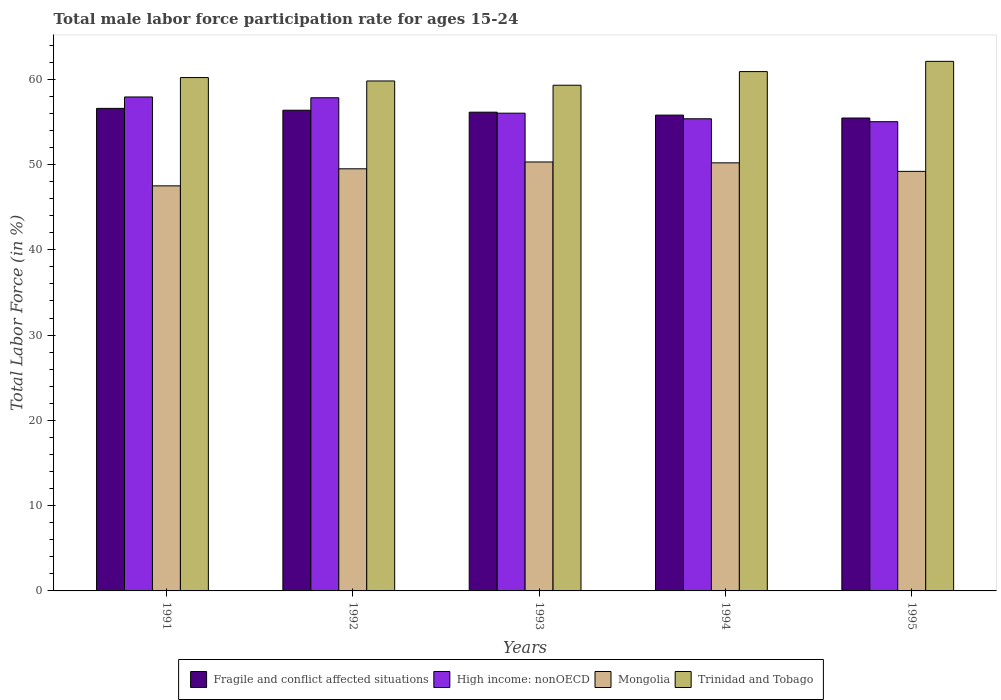How many bars are there on the 4th tick from the right?
Make the answer very short. 4. What is the male labor force participation rate in Trinidad and Tobago in 1994?
Provide a succinct answer. 60.9. Across all years, what is the maximum male labor force participation rate in Fragile and conflict affected situations?
Provide a succinct answer. 56.59. Across all years, what is the minimum male labor force participation rate in Trinidad and Tobago?
Provide a succinct answer. 59.3. In which year was the male labor force participation rate in Mongolia maximum?
Keep it short and to the point. 1993. What is the total male labor force participation rate in Mongolia in the graph?
Your response must be concise. 246.7. What is the difference between the male labor force participation rate in Trinidad and Tobago in 1991 and that in 1994?
Provide a short and direct response. -0.7. What is the difference between the male labor force participation rate in Fragile and conflict affected situations in 1994 and the male labor force participation rate in Trinidad and Tobago in 1995?
Provide a succinct answer. -6.3. What is the average male labor force participation rate in High income: nonOECD per year?
Keep it short and to the point. 56.43. In the year 1995, what is the difference between the male labor force participation rate in High income: nonOECD and male labor force participation rate in Fragile and conflict affected situations?
Make the answer very short. -0.43. What is the ratio of the male labor force participation rate in Trinidad and Tobago in 1992 to that in 1993?
Offer a terse response. 1.01. Is the male labor force participation rate in Fragile and conflict affected situations in 1991 less than that in 1993?
Provide a succinct answer. No. Is the difference between the male labor force participation rate in High income: nonOECD in 1992 and 1994 greater than the difference between the male labor force participation rate in Fragile and conflict affected situations in 1992 and 1994?
Give a very brief answer. Yes. What is the difference between the highest and the second highest male labor force participation rate in Mongolia?
Give a very brief answer. 0.1. What is the difference between the highest and the lowest male labor force participation rate in Mongolia?
Provide a succinct answer. 2.8. In how many years, is the male labor force participation rate in Trinidad and Tobago greater than the average male labor force participation rate in Trinidad and Tobago taken over all years?
Keep it short and to the point. 2. Is the sum of the male labor force participation rate in Fragile and conflict affected situations in 1993 and 1995 greater than the maximum male labor force participation rate in Mongolia across all years?
Your answer should be compact. Yes. What does the 2nd bar from the left in 1994 represents?
Provide a succinct answer. High income: nonOECD. What does the 1st bar from the right in 1994 represents?
Make the answer very short. Trinidad and Tobago. Are the values on the major ticks of Y-axis written in scientific E-notation?
Offer a terse response. No. Does the graph contain any zero values?
Provide a succinct answer. No. Where does the legend appear in the graph?
Offer a very short reply. Bottom center. How many legend labels are there?
Your answer should be compact. 4. How are the legend labels stacked?
Offer a terse response. Horizontal. What is the title of the graph?
Give a very brief answer. Total male labor force participation rate for ages 15-24. Does "Slovak Republic" appear as one of the legend labels in the graph?
Your response must be concise. No. What is the label or title of the X-axis?
Keep it short and to the point. Years. What is the label or title of the Y-axis?
Keep it short and to the point. Total Labor Force (in %). What is the Total Labor Force (in %) of Fragile and conflict affected situations in 1991?
Offer a very short reply. 56.59. What is the Total Labor Force (in %) of High income: nonOECD in 1991?
Make the answer very short. 57.92. What is the Total Labor Force (in %) of Mongolia in 1991?
Offer a very short reply. 47.5. What is the Total Labor Force (in %) of Trinidad and Tobago in 1991?
Make the answer very short. 60.2. What is the Total Labor Force (in %) of Fragile and conflict affected situations in 1992?
Provide a succinct answer. 56.37. What is the Total Labor Force (in %) of High income: nonOECD in 1992?
Provide a succinct answer. 57.83. What is the Total Labor Force (in %) of Mongolia in 1992?
Provide a succinct answer. 49.5. What is the Total Labor Force (in %) of Trinidad and Tobago in 1992?
Your response must be concise. 59.8. What is the Total Labor Force (in %) of Fragile and conflict affected situations in 1993?
Your answer should be very brief. 56.14. What is the Total Labor Force (in %) in High income: nonOECD in 1993?
Offer a terse response. 56.02. What is the Total Labor Force (in %) of Mongolia in 1993?
Keep it short and to the point. 50.3. What is the Total Labor Force (in %) in Trinidad and Tobago in 1993?
Provide a succinct answer. 59.3. What is the Total Labor Force (in %) of Fragile and conflict affected situations in 1994?
Your answer should be compact. 55.8. What is the Total Labor Force (in %) of High income: nonOECD in 1994?
Give a very brief answer. 55.37. What is the Total Labor Force (in %) in Mongolia in 1994?
Make the answer very short. 50.2. What is the Total Labor Force (in %) in Trinidad and Tobago in 1994?
Give a very brief answer. 60.9. What is the Total Labor Force (in %) in Fragile and conflict affected situations in 1995?
Make the answer very short. 55.45. What is the Total Labor Force (in %) of High income: nonOECD in 1995?
Your answer should be very brief. 55.02. What is the Total Labor Force (in %) of Mongolia in 1995?
Offer a very short reply. 49.2. What is the Total Labor Force (in %) in Trinidad and Tobago in 1995?
Your answer should be compact. 62.1. Across all years, what is the maximum Total Labor Force (in %) of Fragile and conflict affected situations?
Give a very brief answer. 56.59. Across all years, what is the maximum Total Labor Force (in %) of High income: nonOECD?
Make the answer very short. 57.92. Across all years, what is the maximum Total Labor Force (in %) of Mongolia?
Your response must be concise. 50.3. Across all years, what is the maximum Total Labor Force (in %) in Trinidad and Tobago?
Your response must be concise. 62.1. Across all years, what is the minimum Total Labor Force (in %) in Fragile and conflict affected situations?
Your answer should be compact. 55.45. Across all years, what is the minimum Total Labor Force (in %) of High income: nonOECD?
Give a very brief answer. 55.02. Across all years, what is the minimum Total Labor Force (in %) of Mongolia?
Give a very brief answer. 47.5. Across all years, what is the minimum Total Labor Force (in %) of Trinidad and Tobago?
Give a very brief answer. 59.3. What is the total Total Labor Force (in %) of Fragile and conflict affected situations in the graph?
Ensure brevity in your answer.  280.35. What is the total Total Labor Force (in %) in High income: nonOECD in the graph?
Ensure brevity in your answer.  282.17. What is the total Total Labor Force (in %) of Mongolia in the graph?
Give a very brief answer. 246.7. What is the total Total Labor Force (in %) in Trinidad and Tobago in the graph?
Your response must be concise. 302.3. What is the difference between the Total Labor Force (in %) of Fragile and conflict affected situations in 1991 and that in 1992?
Make the answer very short. 0.22. What is the difference between the Total Labor Force (in %) of High income: nonOECD in 1991 and that in 1992?
Make the answer very short. 0.09. What is the difference between the Total Labor Force (in %) in Trinidad and Tobago in 1991 and that in 1992?
Your response must be concise. 0.4. What is the difference between the Total Labor Force (in %) in Fragile and conflict affected situations in 1991 and that in 1993?
Offer a very short reply. 0.45. What is the difference between the Total Labor Force (in %) of High income: nonOECD in 1991 and that in 1993?
Your answer should be compact. 1.9. What is the difference between the Total Labor Force (in %) in Fragile and conflict affected situations in 1991 and that in 1994?
Your answer should be very brief. 0.79. What is the difference between the Total Labor Force (in %) of High income: nonOECD in 1991 and that in 1994?
Provide a short and direct response. 2.56. What is the difference between the Total Labor Force (in %) of Mongolia in 1991 and that in 1994?
Your answer should be very brief. -2.7. What is the difference between the Total Labor Force (in %) in Fragile and conflict affected situations in 1991 and that in 1995?
Your answer should be very brief. 1.13. What is the difference between the Total Labor Force (in %) in High income: nonOECD in 1991 and that in 1995?
Make the answer very short. 2.9. What is the difference between the Total Labor Force (in %) in Trinidad and Tobago in 1991 and that in 1995?
Offer a terse response. -1.9. What is the difference between the Total Labor Force (in %) in Fragile and conflict affected situations in 1992 and that in 1993?
Make the answer very short. 0.23. What is the difference between the Total Labor Force (in %) of High income: nonOECD in 1992 and that in 1993?
Your response must be concise. 1.81. What is the difference between the Total Labor Force (in %) in Fragile and conflict affected situations in 1992 and that in 1994?
Give a very brief answer. 0.57. What is the difference between the Total Labor Force (in %) of High income: nonOECD in 1992 and that in 1994?
Make the answer very short. 2.47. What is the difference between the Total Labor Force (in %) of Mongolia in 1992 and that in 1994?
Your answer should be compact. -0.7. What is the difference between the Total Labor Force (in %) in Fragile and conflict affected situations in 1992 and that in 1995?
Your answer should be compact. 0.92. What is the difference between the Total Labor Force (in %) in High income: nonOECD in 1992 and that in 1995?
Provide a succinct answer. 2.81. What is the difference between the Total Labor Force (in %) in Fragile and conflict affected situations in 1993 and that in 1994?
Keep it short and to the point. 0.34. What is the difference between the Total Labor Force (in %) of High income: nonOECD in 1993 and that in 1994?
Provide a succinct answer. 0.66. What is the difference between the Total Labor Force (in %) in Trinidad and Tobago in 1993 and that in 1994?
Provide a succinct answer. -1.6. What is the difference between the Total Labor Force (in %) of Fragile and conflict affected situations in 1993 and that in 1995?
Your answer should be very brief. 0.69. What is the difference between the Total Labor Force (in %) of High income: nonOECD in 1993 and that in 1995?
Offer a terse response. 1. What is the difference between the Total Labor Force (in %) of Fragile and conflict affected situations in 1994 and that in 1995?
Provide a succinct answer. 0.34. What is the difference between the Total Labor Force (in %) of High income: nonOECD in 1994 and that in 1995?
Ensure brevity in your answer.  0.34. What is the difference between the Total Labor Force (in %) of Mongolia in 1994 and that in 1995?
Provide a succinct answer. 1. What is the difference between the Total Labor Force (in %) in Trinidad and Tobago in 1994 and that in 1995?
Offer a very short reply. -1.2. What is the difference between the Total Labor Force (in %) in Fragile and conflict affected situations in 1991 and the Total Labor Force (in %) in High income: nonOECD in 1992?
Ensure brevity in your answer.  -1.25. What is the difference between the Total Labor Force (in %) in Fragile and conflict affected situations in 1991 and the Total Labor Force (in %) in Mongolia in 1992?
Your answer should be compact. 7.09. What is the difference between the Total Labor Force (in %) in Fragile and conflict affected situations in 1991 and the Total Labor Force (in %) in Trinidad and Tobago in 1992?
Offer a terse response. -3.21. What is the difference between the Total Labor Force (in %) of High income: nonOECD in 1991 and the Total Labor Force (in %) of Mongolia in 1992?
Your answer should be compact. 8.42. What is the difference between the Total Labor Force (in %) of High income: nonOECD in 1991 and the Total Labor Force (in %) of Trinidad and Tobago in 1992?
Offer a terse response. -1.88. What is the difference between the Total Labor Force (in %) in Fragile and conflict affected situations in 1991 and the Total Labor Force (in %) in High income: nonOECD in 1993?
Offer a terse response. 0.56. What is the difference between the Total Labor Force (in %) in Fragile and conflict affected situations in 1991 and the Total Labor Force (in %) in Mongolia in 1993?
Provide a succinct answer. 6.29. What is the difference between the Total Labor Force (in %) in Fragile and conflict affected situations in 1991 and the Total Labor Force (in %) in Trinidad and Tobago in 1993?
Offer a very short reply. -2.71. What is the difference between the Total Labor Force (in %) of High income: nonOECD in 1991 and the Total Labor Force (in %) of Mongolia in 1993?
Keep it short and to the point. 7.62. What is the difference between the Total Labor Force (in %) in High income: nonOECD in 1991 and the Total Labor Force (in %) in Trinidad and Tobago in 1993?
Give a very brief answer. -1.38. What is the difference between the Total Labor Force (in %) in Fragile and conflict affected situations in 1991 and the Total Labor Force (in %) in High income: nonOECD in 1994?
Provide a succinct answer. 1.22. What is the difference between the Total Labor Force (in %) of Fragile and conflict affected situations in 1991 and the Total Labor Force (in %) of Mongolia in 1994?
Ensure brevity in your answer.  6.39. What is the difference between the Total Labor Force (in %) of Fragile and conflict affected situations in 1991 and the Total Labor Force (in %) of Trinidad and Tobago in 1994?
Offer a terse response. -4.31. What is the difference between the Total Labor Force (in %) in High income: nonOECD in 1991 and the Total Labor Force (in %) in Mongolia in 1994?
Give a very brief answer. 7.72. What is the difference between the Total Labor Force (in %) in High income: nonOECD in 1991 and the Total Labor Force (in %) in Trinidad and Tobago in 1994?
Give a very brief answer. -2.98. What is the difference between the Total Labor Force (in %) in Mongolia in 1991 and the Total Labor Force (in %) in Trinidad and Tobago in 1994?
Your answer should be compact. -13.4. What is the difference between the Total Labor Force (in %) of Fragile and conflict affected situations in 1991 and the Total Labor Force (in %) of High income: nonOECD in 1995?
Your answer should be compact. 1.56. What is the difference between the Total Labor Force (in %) in Fragile and conflict affected situations in 1991 and the Total Labor Force (in %) in Mongolia in 1995?
Your answer should be compact. 7.39. What is the difference between the Total Labor Force (in %) of Fragile and conflict affected situations in 1991 and the Total Labor Force (in %) of Trinidad and Tobago in 1995?
Your answer should be very brief. -5.51. What is the difference between the Total Labor Force (in %) of High income: nonOECD in 1991 and the Total Labor Force (in %) of Mongolia in 1995?
Your response must be concise. 8.72. What is the difference between the Total Labor Force (in %) in High income: nonOECD in 1991 and the Total Labor Force (in %) in Trinidad and Tobago in 1995?
Your response must be concise. -4.18. What is the difference between the Total Labor Force (in %) of Mongolia in 1991 and the Total Labor Force (in %) of Trinidad and Tobago in 1995?
Your response must be concise. -14.6. What is the difference between the Total Labor Force (in %) of Fragile and conflict affected situations in 1992 and the Total Labor Force (in %) of High income: nonOECD in 1993?
Ensure brevity in your answer.  0.35. What is the difference between the Total Labor Force (in %) in Fragile and conflict affected situations in 1992 and the Total Labor Force (in %) in Mongolia in 1993?
Provide a succinct answer. 6.07. What is the difference between the Total Labor Force (in %) of Fragile and conflict affected situations in 1992 and the Total Labor Force (in %) of Trinidad and Tobago in 1993?
Your answer should be compact. -2.93. What is the difference between the Total Labor Force (in %) in High income: nonOECD in 1992 and the Total Labor Force (in %) in Mongolia in 1993?
Give a very brief answer. 7.53. What is the difference between the Total Labor Force (in %) in High income: nonOECD in 1992 and the Total Labor Force (in %) in Trinidad and Tobago in 1993?
Give a very brief answer. -1.47. What is the difference between the Total Labor Force (in %) of Fragile and conflict affected situations in 1992 and the Total Labor Force (in %) of Mongolia in 1994?
Offer a terse response. 6.17. What is the difference between the Total Labor Force (in %) in Fragile and conflict affected situations in 1992 and the Total Labor Force (in %) in Trinidad and Tobago in 1994?
Your answer should be very brief. -4.53. What is the difference between the Total Labor Force (in %) of High income: nonOECD in 1992 and the Total Labor Force (in %) of Mongolia in 1994?
Provide a succinct answer. 7.63. What is the difference between the Total Labor Force (in %) of High income: nonOECD in 1992 and the Total Labor Force (in %) of Trinidad and Tobago in 1994?
Your response must be concise. -3.07. What is the difference between the Total Labor Force (in %) in Fragile and conflict affected situations in 1992 and the Total Labor Force (in %) in High income: nonOECD in 1995?
Your answer should be very brief. 1.35. What is the difference between the Total Labor Force (in %) of Fragile and conflict affected situations in 1992 and the Total Labor Force (in %) of Mongolia in 1995?
Your answer should be compact. 7.17. What is the difference between the Total Labor Force (in %) of Fragile and conflict affected situations in 1992 and the Total Labor Force (in %) of Trinidad and Tobago in 1995?
Keep it short and to the point. -5.73. What is the difference between the Total Labor Force (in %) in High income: nonOECD in 1992 and the Total Labor Force (in %) in Mongolia in 1995?
Your answer should be compact. 8.63. What is the difference between the Total Labor Force (in %) in High income: nonOECD in 1992 and the Total Labor Force (in %) in Trinidad and Tobago in 1995?
Give a very brief answer. -4.27. What is the difference between the Total Labor Force (in %) in Fragile and conflict affected situations in 1993 and the Total Labor Force (in %) in High income: nonOECD in 1994?
Offer a terse response. 0.77. What is the difference between the Total Labor Force (in %) of Fragile and conflict affected situations in 1993 and the Total Labor Force (in %) of Mongolia in 1994?
Give a very brief answer. 5.94. What is the difference between the Total Labor Force (in %) of Fragile and conflict affected situations in 1993 and the Total Labor Force (in %) of Trinidad and Tobago in 1994?
Your answer should be compact. -4.76. What is the difference between the Total Labor Force (in %) of High income: nonOECD in 1993 and the Total Labor Force (in %) of Mongolia in 1994?
Provide a succinct answer. 5.82. What is the difference between the Total Labor Force (in %) of High income: nonOECD in 1993 and the Total Labor Force (in %) of Trinidad and Tobago in 1994?
Your answer should be very brief. -4.88. What is the difference between the Total Labor Force (in %) in Fragile and conflict affected situations in 1993 and the Total Labor Force (in %) in High income: nonOECD in 1995?
Make the answer very short. 1.12. What is the difference between the Total Labor Force (in %) in Fragile and conflict affected situations in 1993 and the Total Labor Force (in %) in Mongolia in 1995?
Your response must be concise. 6.94. What is the difference between the Total Labor Force (in %) in Fragile and conflict affected situations in 1993 and the Total Labor Force (in %) in Trinidad and Tobago in 1995?
Keep it short and to the point. -5.96. What is the difference between the Total Labor Force (in %) of High income: nonOECD in 1993 and the Total Labor Force (in %) of Mongolia in 1995?
Your answer should be very brief. 6.82. What is the difference between the Total Labor Force (in %) in High income: nonOECD in 1993 and the Total Labor Force (in %) in Trinidad and Tobago in 1995?
Keep it short and to the point. -6.08. What is the difference between the Total Labor Force (in %) in Fragile and conflict affected situations in 1994 and the Total Labor Force (in %) in High income: nonOECD in 1995?
Make the answer very short. 0.77. What is the difference between the Total Labor Force (in %) in Fragile and conflict affected situations in 1994 and the Total Labor Force (in %) in Mongolia in 1995?
Give a very brief answer. 6.6. What is the difference between the Total Labor Force (in %) in Fragile and conflict affected situations in 1994 and the Total Labor Force (in %) in Trinidad and Tobago in 1995?
Give a very brief answer. -6.3. What is the difference between the Total Labor Force (in %) of High income: nonOECD in 1994 and the Total Labor Force (in %) of Mongolia in 1995?
Offer a very short reply. 6.17. What is the difference between the Total Labor Force (in %) in High income: nonOECD in 1994 and the Total Labor Force (in %) in Trinidad and Tobago in 1995?
Ensure brevity in your answer.  -6.73. What is the average Total Labor Force (in %) in Fragile and conflict affected situations per year?
Your answer should be compact. 56.07. What is the average Total Labor Force (in %) of High income: nonOECD per year?
Your response must be concise. 56.43. What is the average Total Labor Force (in %) in Mongolia per year?
Make the answer very short. 49.34. What is the average Total Labor Force (in %) of Trinidad and Tobago per year?
Give a very brief answer. 60.46. In the year 1991, what is the difference between the Total Labor Force (in %) in Fragile and conflict affected situations and Total Labor Force (in %) in High income: nonOECD?
Your answer should be compact. -1.34. In the year 1991, what is the difference between the Total Labor Force (in %) of Fragile and conflict affected situations and Total Labor Force (in %) of Mongolia?
Offer a very short reply. 9.09. In the year 1991, what is the difference between the Total Labor Force (in %) of Fragile and conflict affected situations and Total Labor Force (in %) of Trinidad and Tobago?
Provide a short and direct response. -3.61. In the year 1991, what is the difference between the Total Labor Force (in %) of High income: nonOECD and Total Labor Force (in %) of Mongolia?
Keep it short and to the point. 10.42. In the year 1991, what is the difference between the Total Labor Force (in %) of High income: nonOECD and Total Labor Force (in %) of Trinidad and Tobago?
Give a very brief answer. -2.28. In the year 1992, what is the difference between the Total Labor Force (in %) of Fragile and conflict affected situations and Total Labor Force (in %) of High income: nonOECD?
Offer a very short reply. -1.46. In the year 1992, what is the difference between the Total Labor Force (in %) of Fragile and conflict affected situations and Total Labor Force (in %) of Mongolia?
Your answer should be compact. 6.87. In the year 1992, what is the difference between the Total Labor Force (in %) of Fragile and conflict affected situations and Total Labor Force (in %) of Trinidad and Tobago?
Provide a succinct answer. -3.43. In the year 1992, what is the difference between the Total Labor Force (in %) of High income: nonOECD and Total Labor Force (in %) of Mongolia?
Offer a very short reply. 8.33. In the year 1992, what is the difference between the Total Labor Force (in %) of High income: nonOECD and Total Labor Force (in %) of Trinidad and Tobago?
Give a very brief answer. -1.97. In the year 1992, what is the difference between the Total Labor Force (in %) in Mongolia and Total Labor Force (in %) in Trinidad and Tobago?
Keep it short and to the point. -10.3. In the year 1993, what is the difference between the Total Labor Force (in %) in Fragile and conflict affected situations and Total Labor Force (in %) in High income: nonOECD?
Offer a very short reply. 0.12. In the year 1993, what is the difference between the Total Labor Force (in %) in Fragile and conflict affected situations and Total Labor Force (in %) in Mongolia?
Keep it short and to the point. 5.84. In the year 1993, what is the difference between the Total Labor Force (in %) in Fragile and conflict affected situations and Total Labor Force (in %) in Trinidad and Tobago?
Your answer should be very brief. -3.16. In the year 1993, what is the difference between the Total Labor Force (in %) of High income: nonOECD and Total Labor Force (in %) of Mongolia?
Your response must be concise. 5.72. In the year 1993, what is the difference between the Total Labor Force (in %) in High income: nonOECD and Total Labor Force (in %) in Trinidad and Tobago?
Your response must be concise. -3.28. In the year 1993, what is the difference between the Total Labor Force (in %) of Mongolia and Total Labor Force (in %) of Trinidad and Tobago?
Ensure brevity in your answer.  -9. In the year 1994, what is the difference between the Total Labor Force (in %) in Fragile and conflict affected situations and Total Labor Force (in %) in High income: nonOECD?
Keep it short and to the point. 0.43. In the year 1994, what is the difference between the Total Labor Force (in %) of Fragile and conflict affected situations and Total Labor Force (in %) of Mongolia?
Your response must be concise. 5.6. In the year 1994, what is the difference between the Total Labor Force (in %) in Fragile and conflict affected situations and Total Labor Force (in %) in Trinidad and Tobago?
Give a very brief answer. -5.1. In the year 1994, what is the difference between the Total Labor Force (in %) of High income: nonOECD and Total Labor Force (in %) of Mongolia?
Offer a terse response. 5.17. In the year 1994, what is the difference between the Total Labor Force (in %) of High income: nonOECD and Total Labor Force (in %) of Trinidad and Tobago?
Offer a very short reply. -5.53. In the year 1994, what is the difference between the Total Labor Force (in %) in Mongolia and Total Labor Force (in %) in Trinidad and Tobago?
Provide a short and direct response. -10.7. In the year 1995, what is the difference between the Total Labor Force (in %) in Fragile and conflict affected situations and Total Labor Force (in %) in High income: nonOECD?
Your answer should be very brief. 0.43. In the year 1995, what is the difference between the Total Labor Force (in %) of Fragile and conflict affected situations and Total Labor Force (in %) of Mongolia?
Your answer should be compact. 6.25. In the year 1995, what is the difference between the Total Labor Force (in %) in Fragile and conflict affected situations and Total Labor Force (in %) in Trinidad and Tobago?
Your answer should be compact. -6.65. In the year 1995, what is the difference between the Total Labor Force (in %) in High income: nonOECD and Total Labor Force (in %) in Mongolia?
Give a very brief answer. 5.82. In the year 1995, what is the difference between the Total Labor Force (in %) in High income: nonOECD and Total Labor Force (in %) in Trinidad and Tobago?
Offer a very short reply. -7.08. What is the ratio of the Total Labor Force (in %) in Fragile and conflict affected situations in 1991 to that in 1992?
Offer a very short reply. 1. What is the ratio of the Total Labor Force (in %) in High income: nonOECD in 1991 to that in 1992?
Offer a very short reply. 1. What is the ratio of the Total Labor Force (in %) of Mongolia in 1991 to that in 1992?
Make the answer very short. 0.96. What is the ratio of the Total Labor Force (in %) of Trinidad and Tobago in 1991 to that in 1992?
Offer a terse response. 1.01. What is the ratio of the Total Labor Force (in %) of Fragile and conflict affected situations in 1991 to that in 1993?
Offer a terse response. 1.01. What is the ratio of the Total Labor Force (in %) of High income: nonOECD in 1991 to that in 1993?
Offer a terse response. 1.03. What is the ratio of the Total Labor Force (in %) in Mongolia in 1991 to that in 1993?
Offer a terse response. 0.94. What is the ratio of the Total Labor Force (in %) in Trinidad and Tobago in 1991 to that in 1993?
Your answer should be very brief. 1.02. What is the ratio of the Total Labor Force (in %) in Fragile and conflict affected situations in 1991 to that in 1994?
Keep it short and to the point. 1.01. What is the ratio of the Total Labor Force (in %) of High income: nonOECD in 1991 to that in 1994?
Keep it short and to the point. 1.05. What is the ratio of the Total Labor Force (in %) of Mongolia in 1991 to that in 1994?
Keep it short and to the point. 0.95. What is the ratio of the Total Labor Force (in %) of Trinidad and Tobago in 1991 to that in 1994?
Keep it short and to the point. 0.99. What is the ratio of the Total Labor Force (in %) of Fragile and conflict affected situations in 1991 to that in 1995?
Your answer should be compact. 1.02. What is the ratio of the Total Labor Force (in %) of High income: nonOECD in 1991 to that in 1995?
Provide a short and direct response. 1.05. What is the ratio of the Total Labor Force (in %) in Mongolia in 1991 to that in 1995?
Offer a very short reply. 0.97. What is the ratio of the Total Labor Force (in %) of Trinidad and Tobago in 1991 to that in 1995?
Your response must be concise. 0.97. What is the ratio of the Total Labor Force (in %) in Fragile and conflict affected situations in 1992 to that in 1993?
Provide a short and direct response. 1. What is the ratio of the Total Labor Force (in %) in High income: nonOECD in 1992 to that in 1993?
Provide a succinct answer. 1.03. What is the ratio of the Total Labor Force (in %) in Mongolia in 1992 to that in 1993?
Provide a succinct answer. 0.98. What is the ratio of the Total Labor Force (in %) of Trinidad and Tobago in 1992 to that in 1993?
Offer a very short reply. 1.01. What is the ratio of the Total Labor Force (in %) in Fragile and conflict affected situations in 1992 to that in 1994?
Offer a terse response. 1.01. What is the ratio of the Total Labor Force (in %) in High income: nonOECD in 1992 to that in 1994?
Provide a short and direct response. 1.04. What is the ratio of the Total Labor Force (in %) of Mongolia in 1992 to that in 1994?
Provide a succinct answer. 0.99. What is the ratio of the Total Labor Force (in %) of Trinidad and Tobago in 1992 to that in 1994?
Ensure brevity in your answer.  0.98. What is the ratio of the Total Labor Force (in %) in Fragile and conflict affected situations in 1992 to that in 1995?
Make the answer very short. 1.02. What is the ratio of the Total Labor Force (in %) of High income: nonOECD in 1992 to that in 1995?
Keep it short and to the point. 1.05. What is the ratio of the Total Labor Force (in %) in Trinidad and Tobago in 1992 to that in 1995?
Make the answer very short. 0.96. What is the ratio of the Total Labor Force (in %) of High income: nonOECD in 1993 to that in 1994?
Give a very brief answer. 1.01. What is the ratio of the Total Labor Force (in %) in Mongolia in 1993 to that in 1994?
Give a very brief answer. 1. What is the ratio of the Total Labor Force (in %) in Trinidad and Tobago in 1993 to that in 1994?
Ensure brevity in your answer.  0.97. What is the ratio of the Total Labor Force (in %) in Fragile and conflict affected situations in 1993 to that in 1995?
Provide a succinct answer. 1.01. What is the ratio of the Total Labor Force (in %) in High income: nonOECD in 1993 to that in 1995?
Your answer should be compact. 1.02. What is the ratio of the Total Labor Force (in %) of Mongolia in 1993 to that in 1995?
Offer a terse response. 1.02. What is the ratio of the Total Labor Force (in %) of Trinidad and Tobago in 1993 to that in 1995?
Offer a terse response. 0.95. What is the ratio of the Total Labor Force (in %) of Fragile and conflict affected situations in 1994 to that in 1995?
Ensure brevity in your answer.  1.01. What is the ratio of the Total Labor Force (in %) in High income: nonOECD in 1994 to that in 1995?
Make the answer very short. 1.01. What is the ratio of the Total Labor Force (in %) in Mongolia in 1994 to that in 1995?
Offer a very short reply. 1.02. What is the ratio of the Total Labor Force (in %) of Trinidad and Tobago in 1994 to that in 1995?
Your answer should be compact. 0.98. What is the difference between the highest and the second highest Total Labor Force (in %) of Fragile and conflict affected situations?
Your response must be concise. 0.22. What is the difference between the highest and the second highest Total Labor Force (in %) in High income: nonOECD?
Your response must be concise. 0.09. What is the difference between the highest and the lowest Total Labor Force (in %) of Fragile and conflict affected situations?
Offer a very short reply. 1.13. What is the difference between the highest and the lowest Total Labor Force (in %) in High income: nonOECD?
Your response must be concise. 2.9. What is the difference between the highest and the lowest Total Labor Force (in %) of Trinidad and Tobago?
Give a very brief answer. 2.8. 